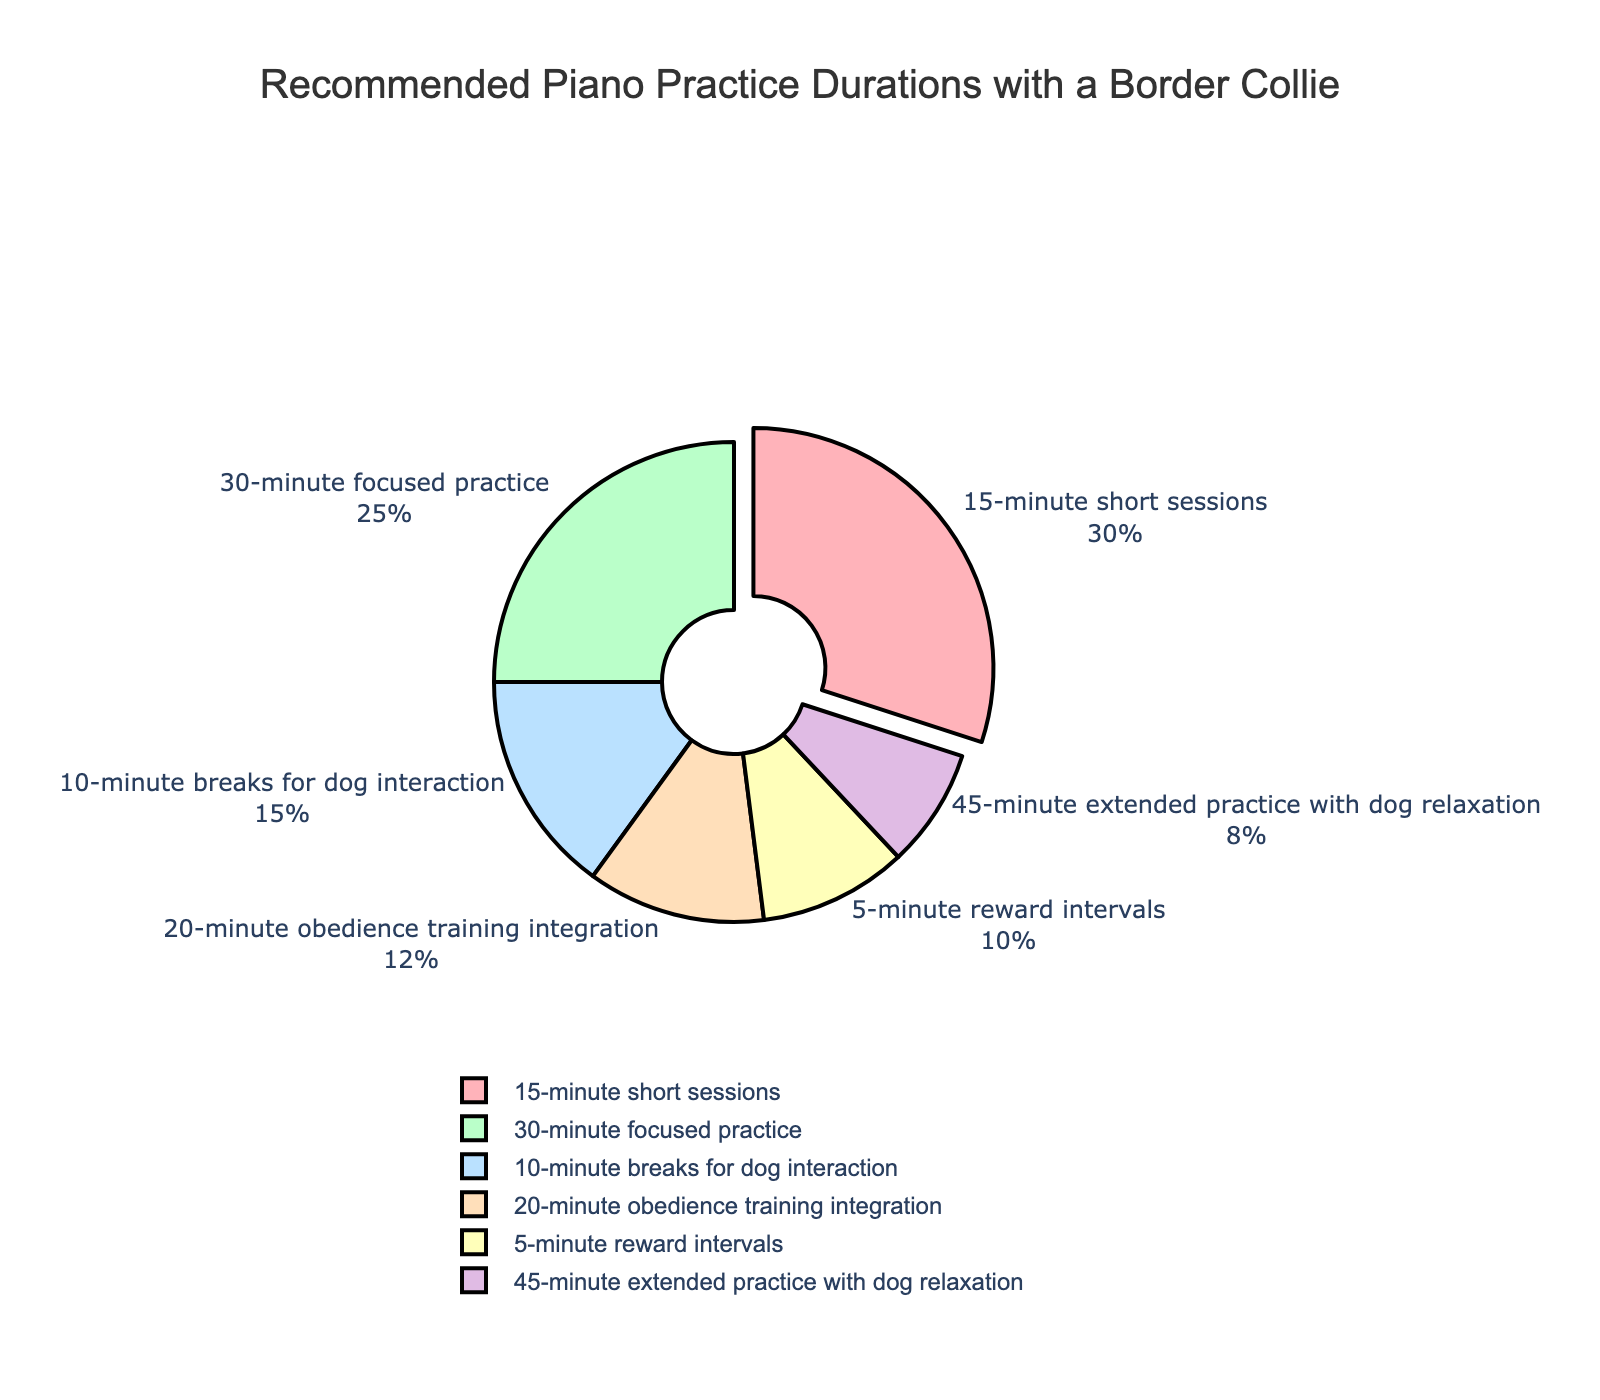How much total time is allocated for interaction with the dog during practice? Add the percentages for "10-minute breaks for dog interaction" and "5-minute reward intervals": 15% + 10% = 25%
Answer: 25% Which duration has the highest percentage in the pie chart? Look for the duration with the highest percentage, which is "15-minute short sessions" with 30%.
Answer: 15-minute short sessions How does the percentage of "30-minute focused practice" compare to "45-minute extended practice with dog relaxation"? Compare the percentages: 25% for "30-minute focused practice" and 8% for "45-minute extended practice with dog relaxation". 25% is greater than 8%.
Answer: 30-minute focused practice is higher What color represents the "20-minute obedience training integration" segment? Identify the color for the "20-minute obedience training integration" segment in the pie chart. The color is pale orange.
Answer: Pale orange What is the combined percentage of "15-minute short sessions" and "30-minute focused practice"? Sum the percentages of "15-minute short sessions" and "30-minute focused practice": 30% + 25% = 55%.
Answer: 55% How much larger is the "15-minute short sessions" segment compared to the "5-minute reward intervals" segment? Subtract the percentage of "5-minute reward intervals" from the "15-minute short sessions": 30% - 10% = 20%.
Answer: 20% Which two durations are represented by segments colored in shades of green? Identify the segments colored in shades of green: "30-minute focused practice" (light green) and "20-minute obedience training integration" (pale green).
Answer: 30-minute focused practice and 20-minute obedience training integration If we combine the percentages for "15-minute short sessions" and "10-minute breaks for dog interaction," what fraction of the pie chart do they represent? Sum the percentages for the two durations: 30% + 15% = 45%, which is 45/100 or simplified as 9/20.
Answer: 9/20 Which duration contributes the least to the overall practice time, and what is its percentage? Locate the segment with the smallest percentage: "45-minute extended practice with dog relaxation" at 8%.
Answer: 45-minute extended practice with dog relaxation, 8% What is the average percentage of the durations that integrate dog activities ("10-minute breaks for dog interaction", "5-minute reward intervals", "20-minute obedience training integration")? Compute the average: (15% + 10% + 12%) / 3 = 37% / 3 ≈ 12.33%.
Answer: 12.33% 